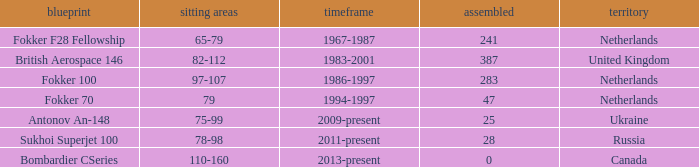How many cabins were built in the time between 1967-1987? 241.0. 